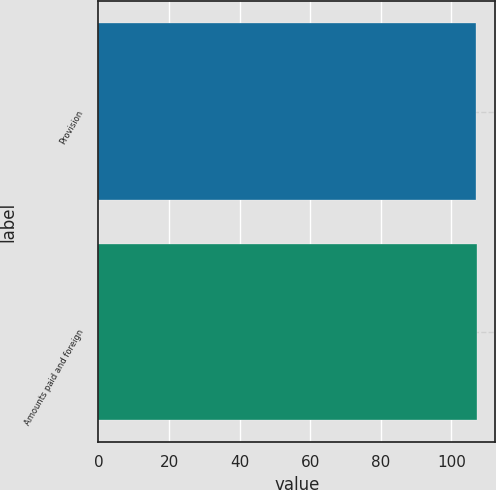Convert chart to OTSL. <chart><loc_0><loc_0><loc_500><loc_500><bar_chart><fcel>Provision<fcel>Amounts paid and foreign<nl><fcel>107<fcel>107.1<nl></chart> 